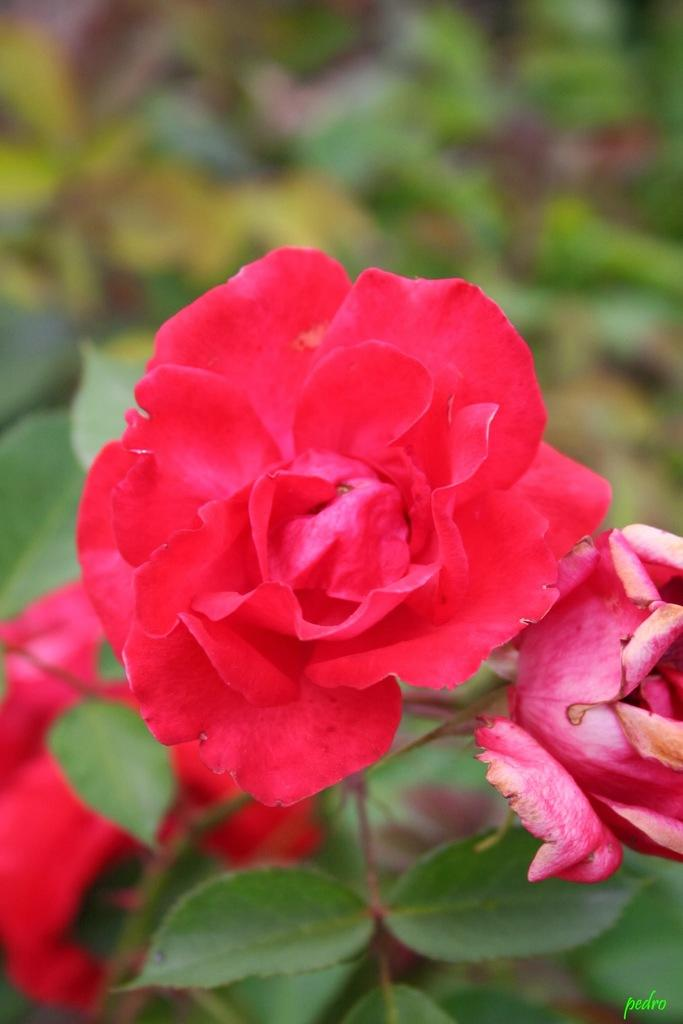What type of flowers are in the image? There are three red roses in the image. How would you describe the appearance of the roses? The roses are beautiful. What other parts of the plant are visible in the image? The roses have leaves. Can you describe the background of the image? The background of the image is blurry. What type of feast is being held in the garden in the image? There is no feast or garden present in the image; it features three red roses with leaves and a blurry background. What discovery was made in the garden in the image? There is no discovery or garden present in the image. 